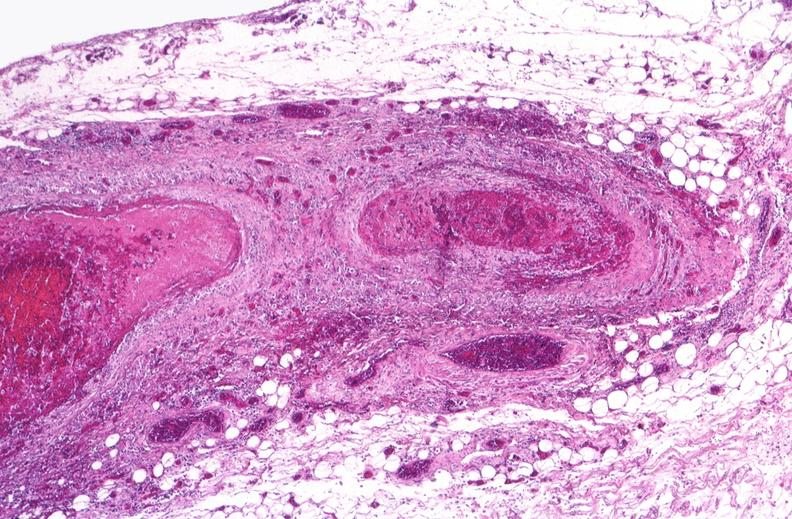what is present?
Answer the question using a single word or phrase. Vasculature 